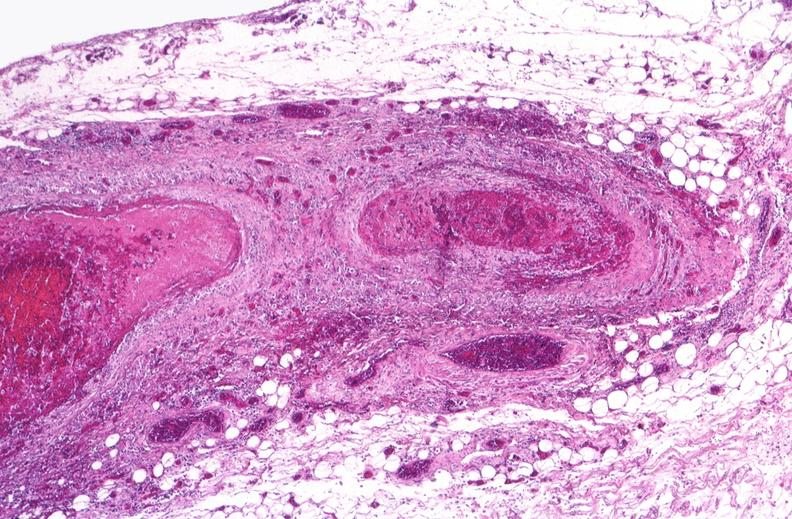what is present?
Answer the question using a single word or phrase. Vasculature 